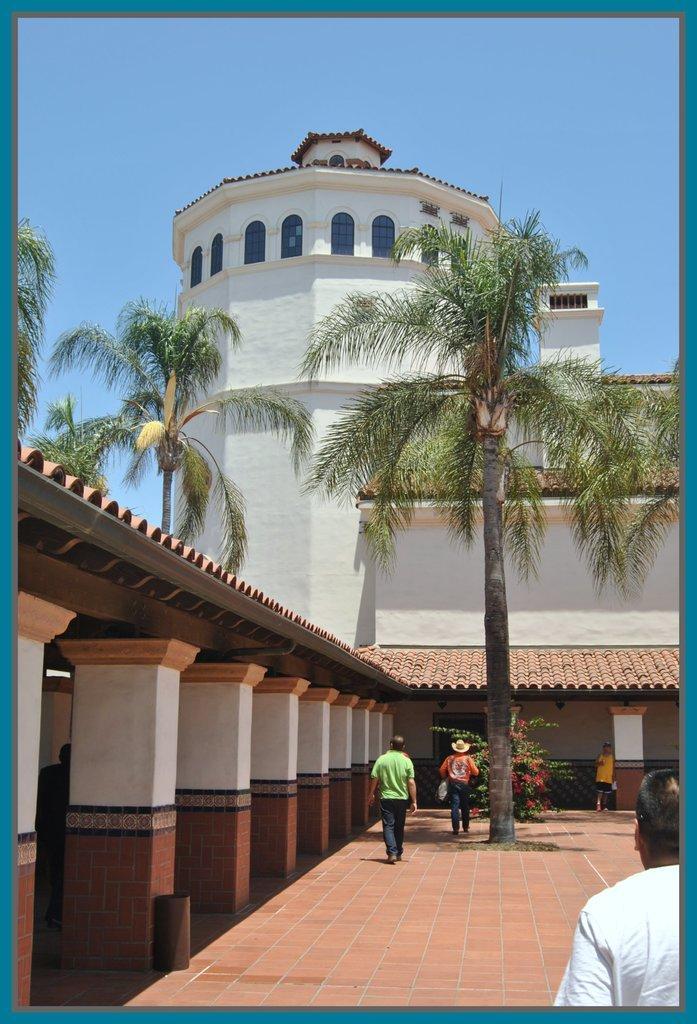What type of structure is present in the image? There is a building in the image. What natural elements can be seen in the image? There are trees in the image. What architectural feature is visible at the bottom of the image? Pillars are visible at the bottom of the image. Who or what is present in the image? There are people in the image. What can be seen in the background of the image? The sky is visible in the background of the image. What type of tooth is visible in the image? There is no tooth present in the image. What kind of fowl can be seen in the image? There is no fowl present in the image. 